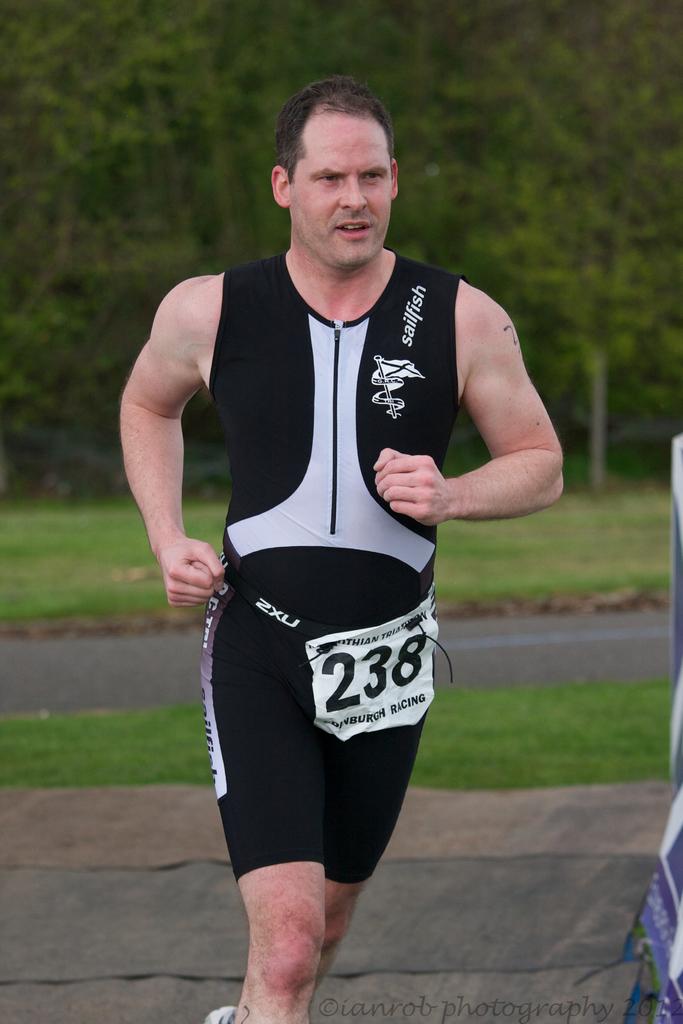What does the top right of the runner's shirt say?
Make the answer very short. Sailfish. 